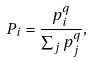Convert formula to latex. <formula><loc_0><loc_0><loc_500><loc_500>P _ { i } = \frac { p _ { i } ^ { q } } { \sum _ { j } p _ { j } ^ { q } } ,</formula> 